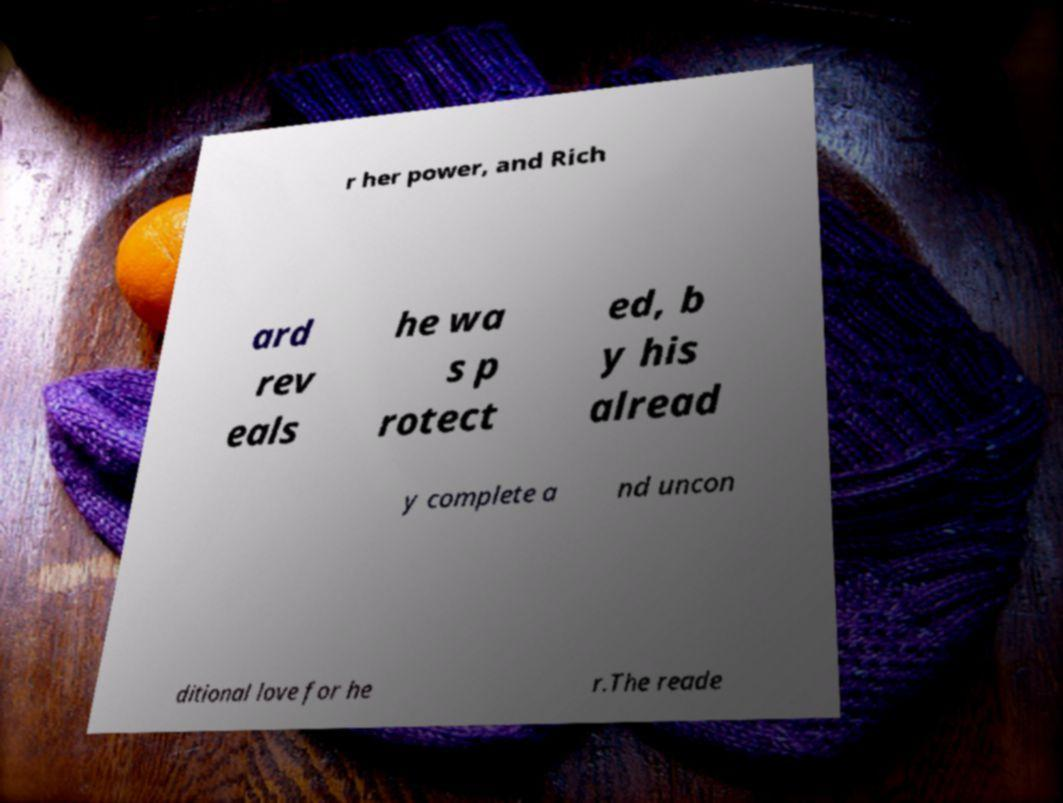Can you read and provide the text displayed in the image?This photo seems to have some interesting text. Can you extract and type it out for me? r her power, and Rich ard rev eals he wa s p rotect ed, b y his alread y complete a nd uncon ditional love for he r.The reade 